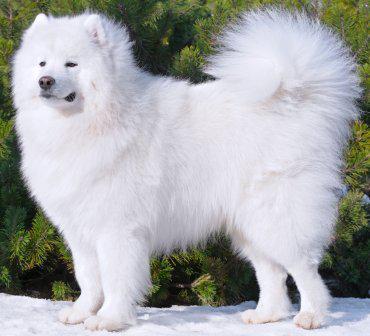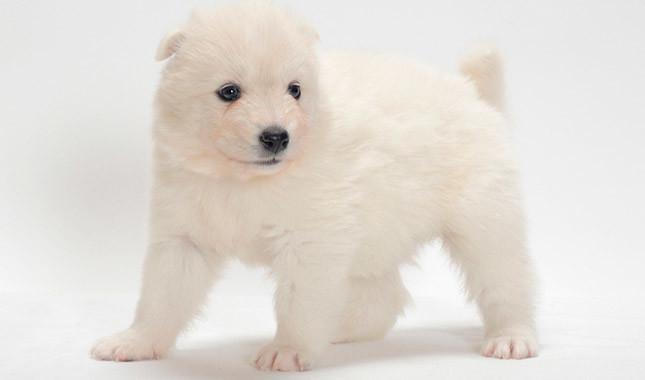The first image is the image on the left, the second image is the image on the right. Examine the images to the left and right. Is the description "In one image there is a dog outside in the center of the image." accurate? Answer yes or no. Yes. The first image is the image on the left, the second image is the image on the right. Examine the images to the left and right. Is the description "At least one dog's tongue is visible." accurate? Answer yes or no. No. 